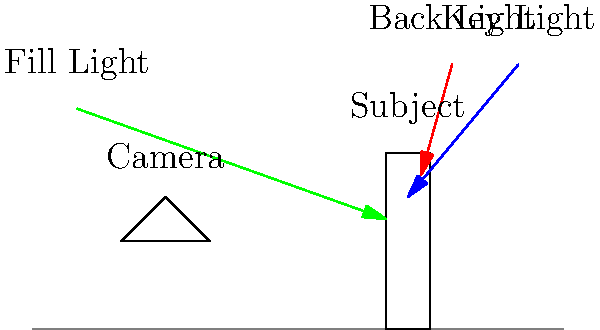In a night shoot for a Bengali film, you're setting up a three-point lighting system. Based on the diagram, which light source is likely to create the most dramatic shadows and define the subject's silhouette? To answer this question, let's analyze the three-point lighting setup in the diagram:

1. Key Light (Blue arrow):
   - Positioned at the top right of the subject
   - Main light source, providing primary illumination

2. Fill Light (Green arrow):
   - Positioned at the top left of the subject
   - Softer light, used to reduce shadows created by the key light

3. Back Light (Red arrow):
   - Positioned behind and above the subject
   - Separates the subject from the background

The back light, also known as the rim light or hair light, is typically used to create a subtle glow around the edges of the subject. This light defines the subject's silhouette and creates separation from the background, which is especially important in low-light or night scenes.

In a night shoot, the contrast between the dark background and the illuminated edges of the subject created by the back light will be more pronounced. This creates a dramatic effect, enhancing the subject's form and adding depth to the shot.

While the key light is the main source of illumination and can create strong shadows, it's the back light that will most effectively define the subject's silhouette and create the most dramatic effect in a night scene.
Answer: Back Light 